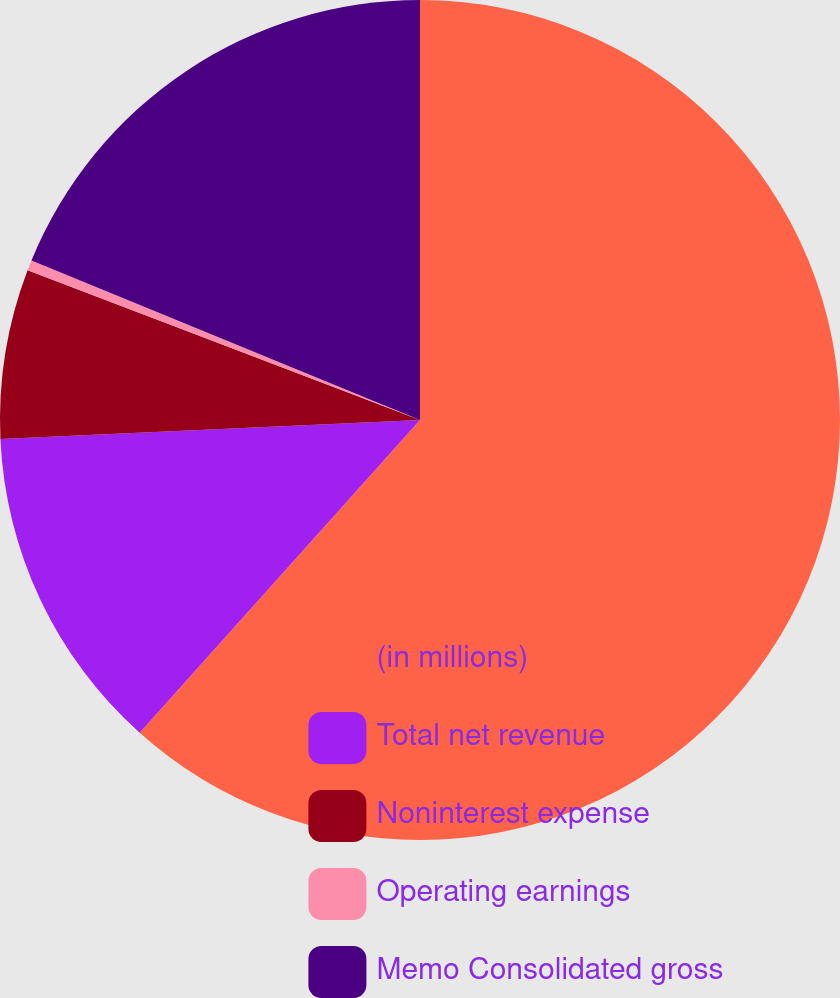<chart> <loc_0><loc_0><loc_500><loc_500><pie_chart><fcel>(in millions)<fcel>Total net revenue<fcel>Noninterest expense<fcel>Operating earnings<fcel>Memo Consolidated gross<nl><fcel>61.63%<fcel>12.65%<fcel>6.52%<fcel>0.4%<fcel>18.8%<nl></chart> 